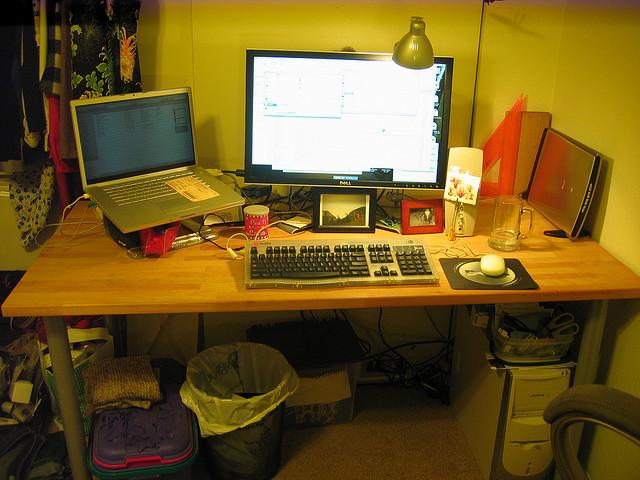What kind of cup is sat on the desk next to the computer mouse? mug 